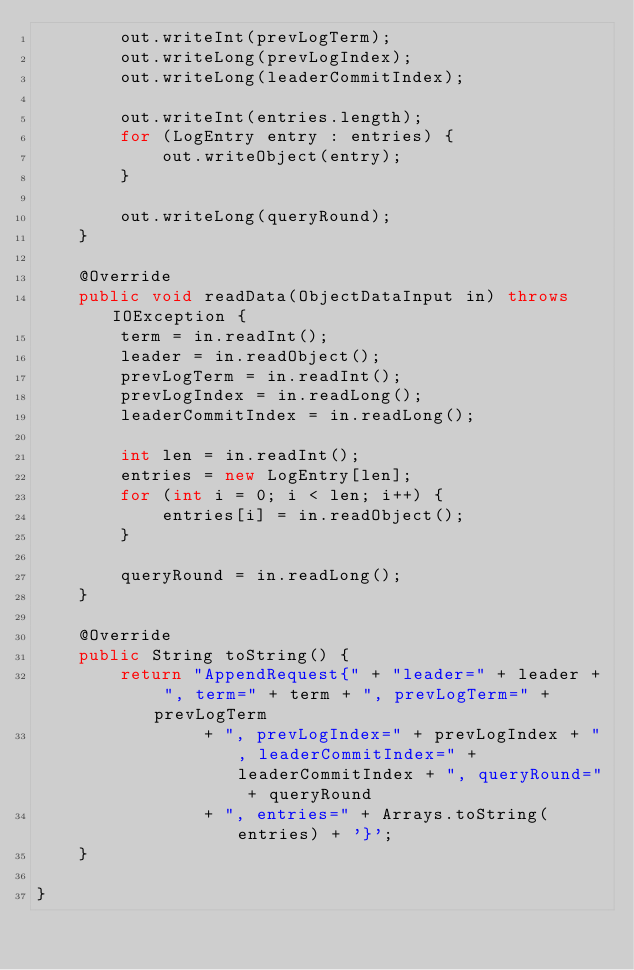<code> <loc_0><loc_0><loc_500><loc_500><_Java_>        out.writeInt(prevLogTerm);
        out.writeLong(prevLogIndex);
        out.writeLong(leaderCommitIndex);

        out.writeInt(entries.length);
        for (LogEntry entry : entries) {
            out.writeObject(entry);
        }

        out.writeLong(queryRound);
    }

    @Override
    public void readData(ObjectDataInput in) throws IOException {
        term = in.readInt();
        leader = in.readObject();
        prevLogTerm = in.readInt();
        prevLogIndex = in.readLong();
        leaderCommitIndex = in.readLong();

        int len = in.readInt();
        entries = new LogEntry[len];
        for (int i = 0; i < len; i++) {
            entries[i] = in.readObject();
        }

        queryRound = in.readLong();
    }

    @Override
    public String toString() {
        return "AppendRequest{" + "leader=" + leader + ", term=" + term + ", prevLogTerm=" + prevLogTerm
                + ", prevLogIndex=" + prevLogIndex + ", leaderCommitIndex=" + leaderCommitIndex + ", queryRound=" + queryRound
                + ", entries=" + Arrays.toString(entries) + '}';
    }

}
</code> 